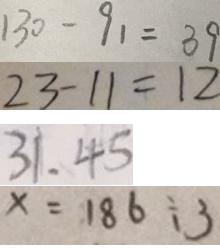<formula> <loc_0><loc_0><loc_500><loc_500>1 3 0 - 9 1 = 3 9 
 2 3 - 1 1 = 1 2 
 3 1 . 4 5 
 x = 1 8 6 \div 3</formula> 